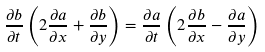Convert formula to latex. <formula><loc_0><loc_0><loc_500><loc_500>\frac { \partial b } { \partial t } \left ( 2 \frac { \partial a } { \partial x } + \frac { \partial b } { \partial y } \right ) = \frac { \partial a } { \partial t } \left ( 2 \frac { \partial b } { \partial x } - \frac { \partial a } { \partial y } \right )</formula> 